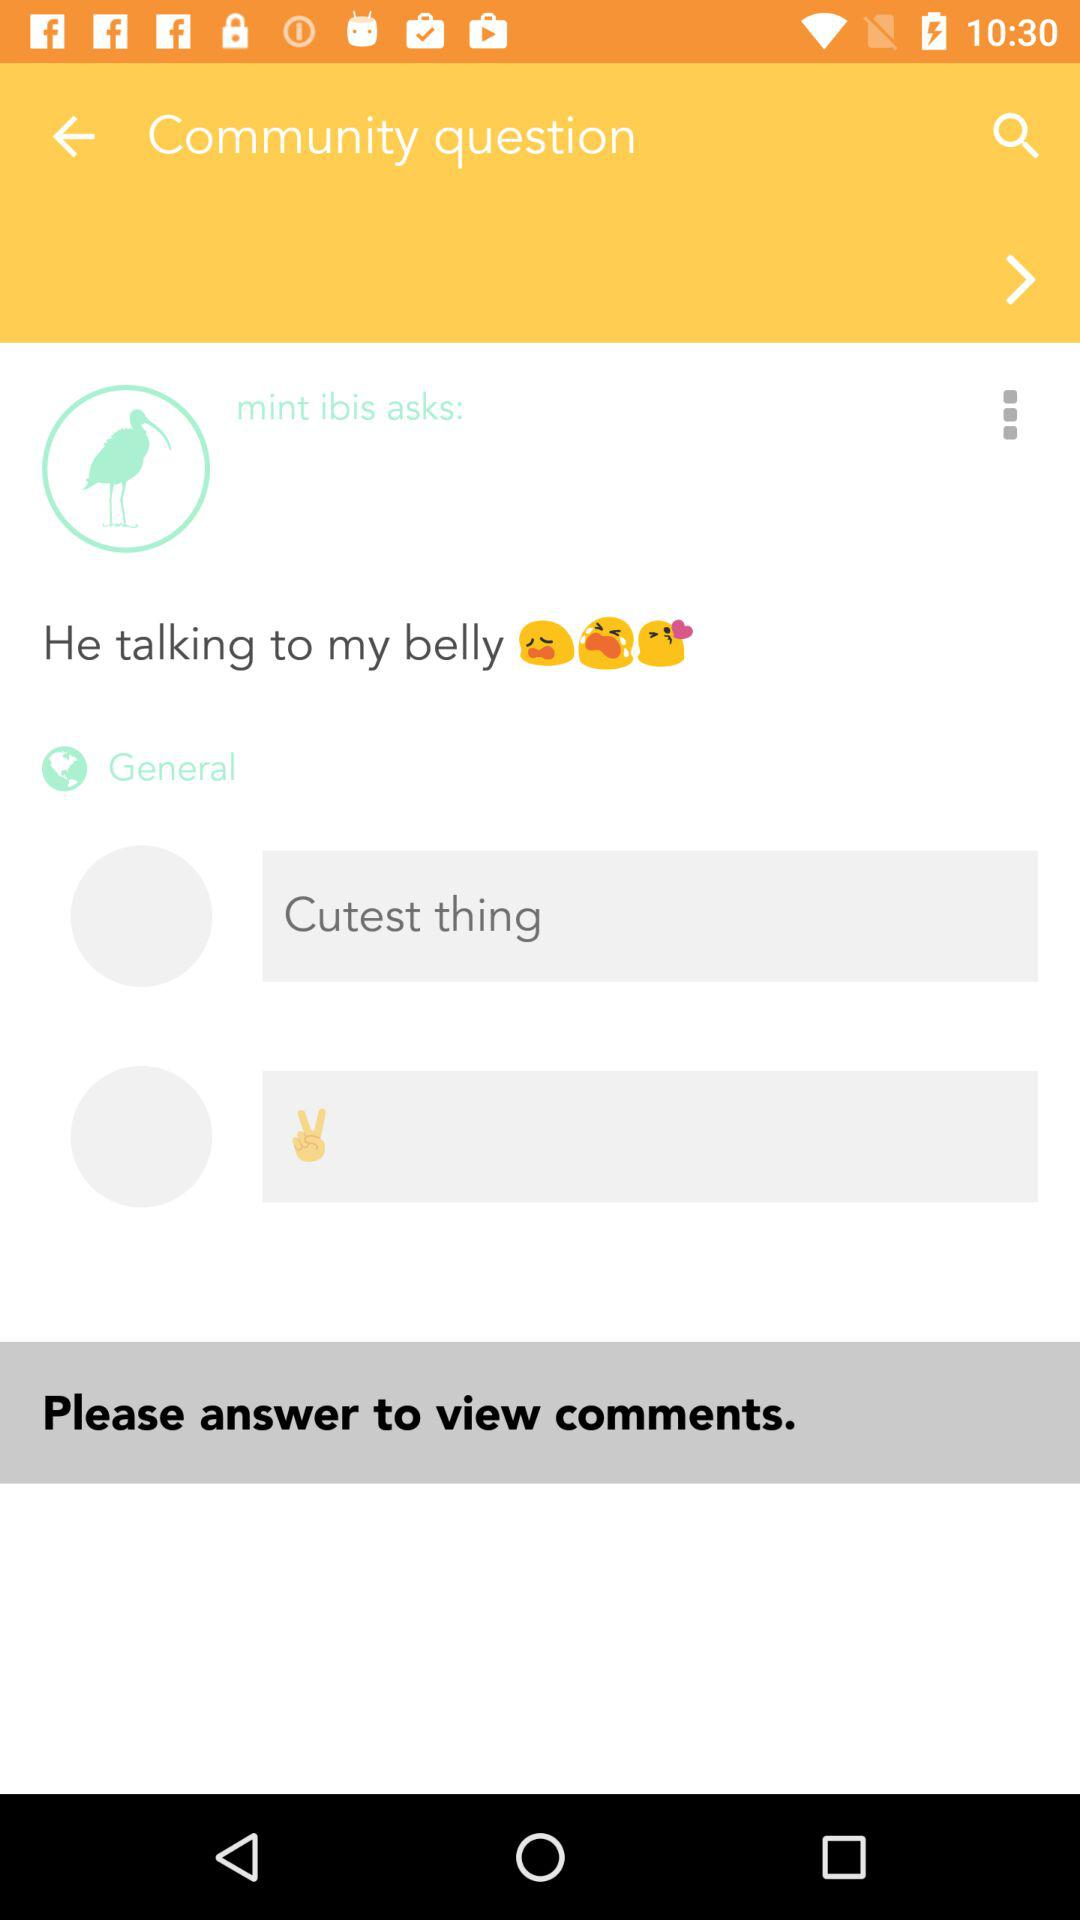What kind of question is asked?
When the provided information is insufficient, respond with <no answer>. <no answer> 